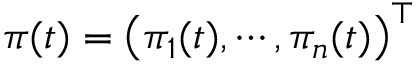Convert formula to latex. <formula><loc_0><loc_0><loc_500><loc_500>\pi ( t ) = { \left ( \pi _ { 1 } ( t ) , \cdots , \pi _ { n } ( t ) \right ) } ^ { \top }</formula> 